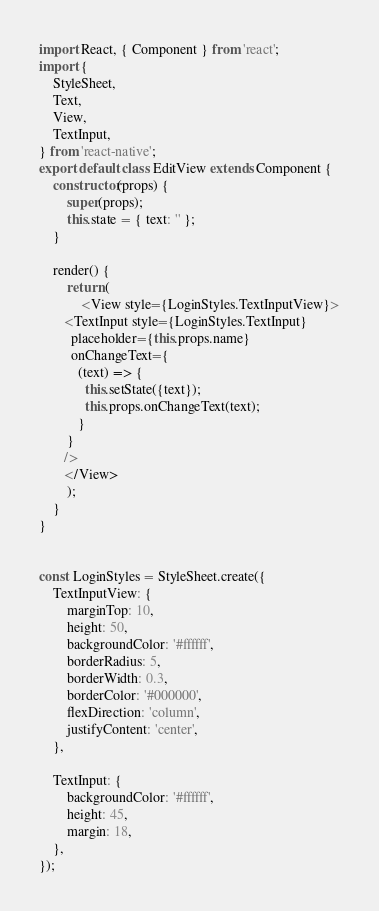<code> <loc_0><loc_0><loc_500><loc_500><_JavaScript_>import React, { Component } from 'react';
import {
    StyleSheet,
    Text,
    View,
    TextInput,
} from 'react-native';
export default class EditView extends Component {
    constructor(props) {
        super(props);
        this.state = { text: '' };
    }

    render() {
        return (
            <View style={LoginStyles.TextInputView}>
       <TextInput style={LoginStyles.TextInput}
         placeholder={this.props.name}
         onChangeText={
           (text) => {
             this.setState({text});
             this.props.onChangeText(text);
           }
        }
       />
       </View>
        );
    }
}


const LoginStyles = StyleSheet.create({
    TextInputView: {
        marginTop: 10,
        height: 50,
        backgroundColor: '#ffffff',
        borderRadius: 5,
        borderWidth: 0.3,
        borderColor: '#000000',
        flexDirection: 'column',
        justifyContent: 'center',
    },

    TextInput: {
        backgroundColor: '#ffffff',
        height: 45,
        margin: 18,
    },
});
</code> 